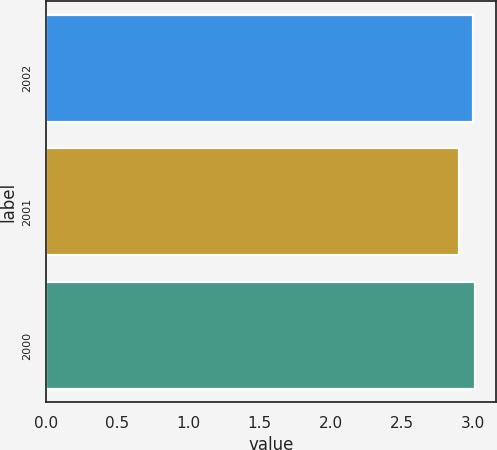Convert chart. <chart><loc_0><loc_0><loc_500><loc_500><bar_chart><fcel>2002<fcel>2001<fcel>2000<nl><fcel>3<fcel>2.9<fcel>3.01<nl></chart> 